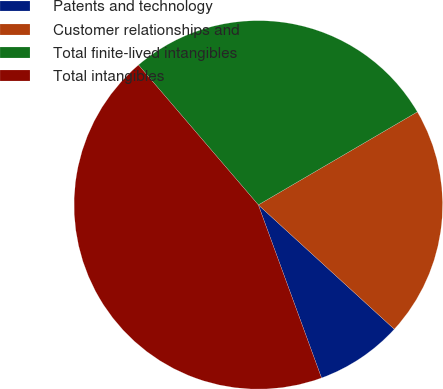Convert chart to OTSL. <chart><loc_0><loc_0><loc_500><loc_500><pie_chart><fcel>Patents and technology<fcel>Customer relationships and<fcel>Total finite-lived intangibles<fcel>Total intangibles<nl><fcel>7.64%<fcel>20.21%<fcel>27.85%<fcel>44.3%<nl></chart> 